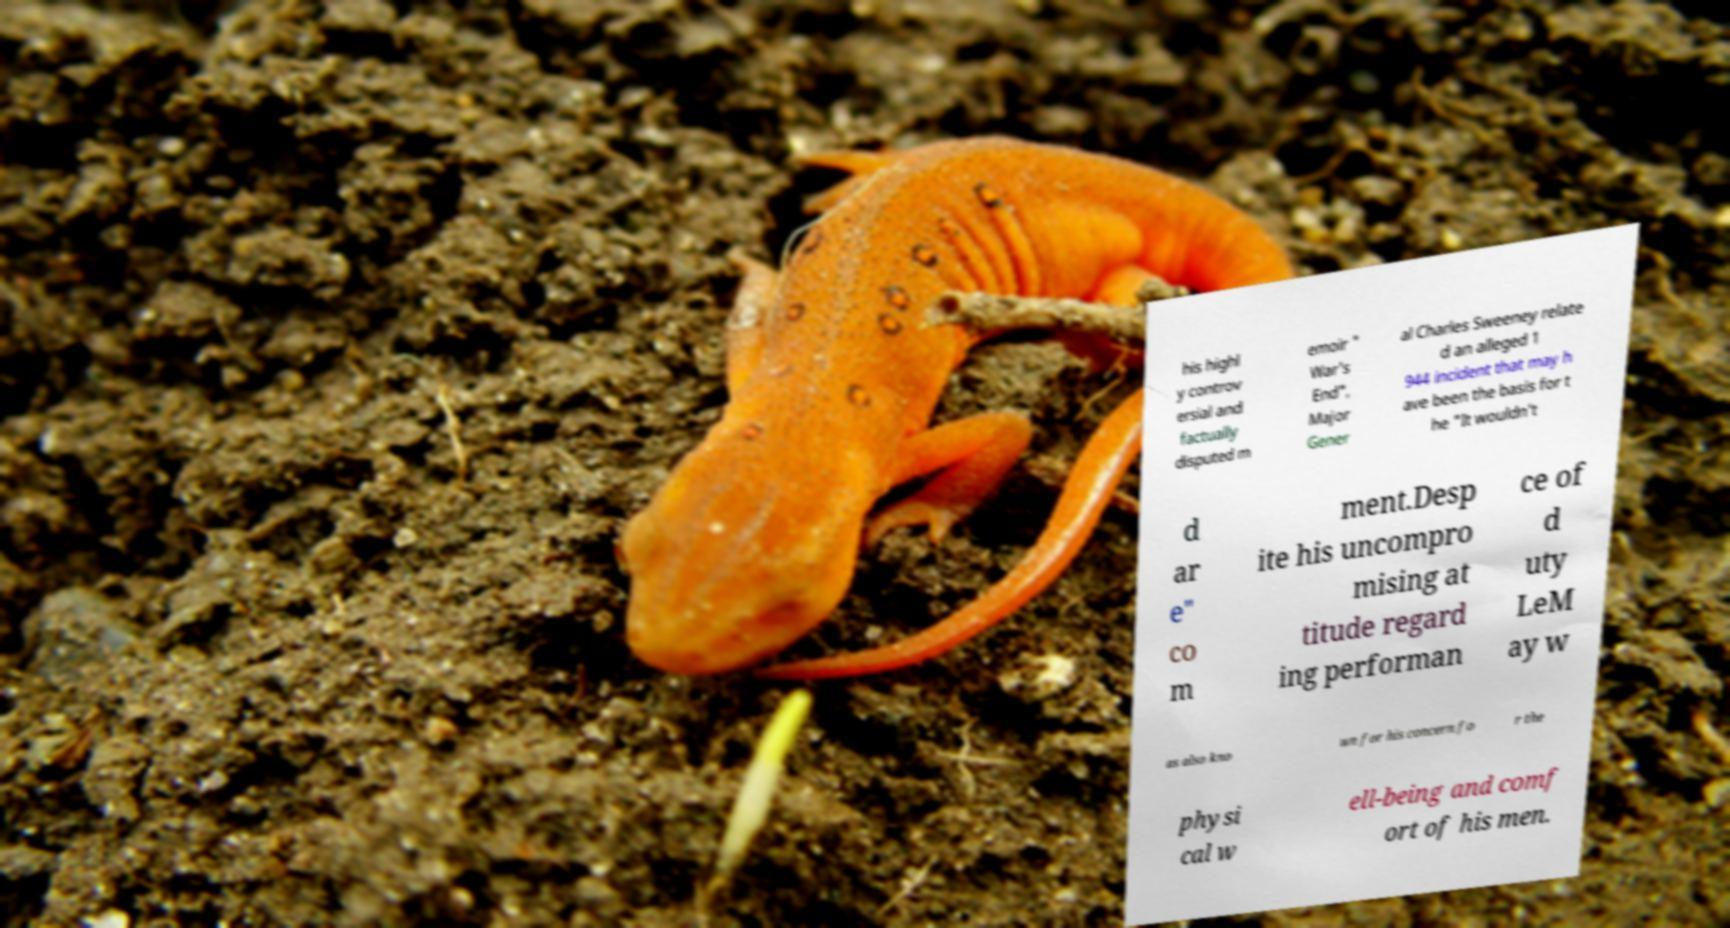Could you extract and type out the text from this image? his highl y controv ersial and factually disputed m emoir " War's End", Major Gener al Charles Sweeney relate d an alleged 1 944 incident that may h ave been the basis for t he "It wouldn't d ar e" co m ment.Desp ite his uncompro mising at titude regard ing performan ce of d uty LeM ay w as also kno wn for his concern fo r the physi cal w ell-being and comf ort of his men. 